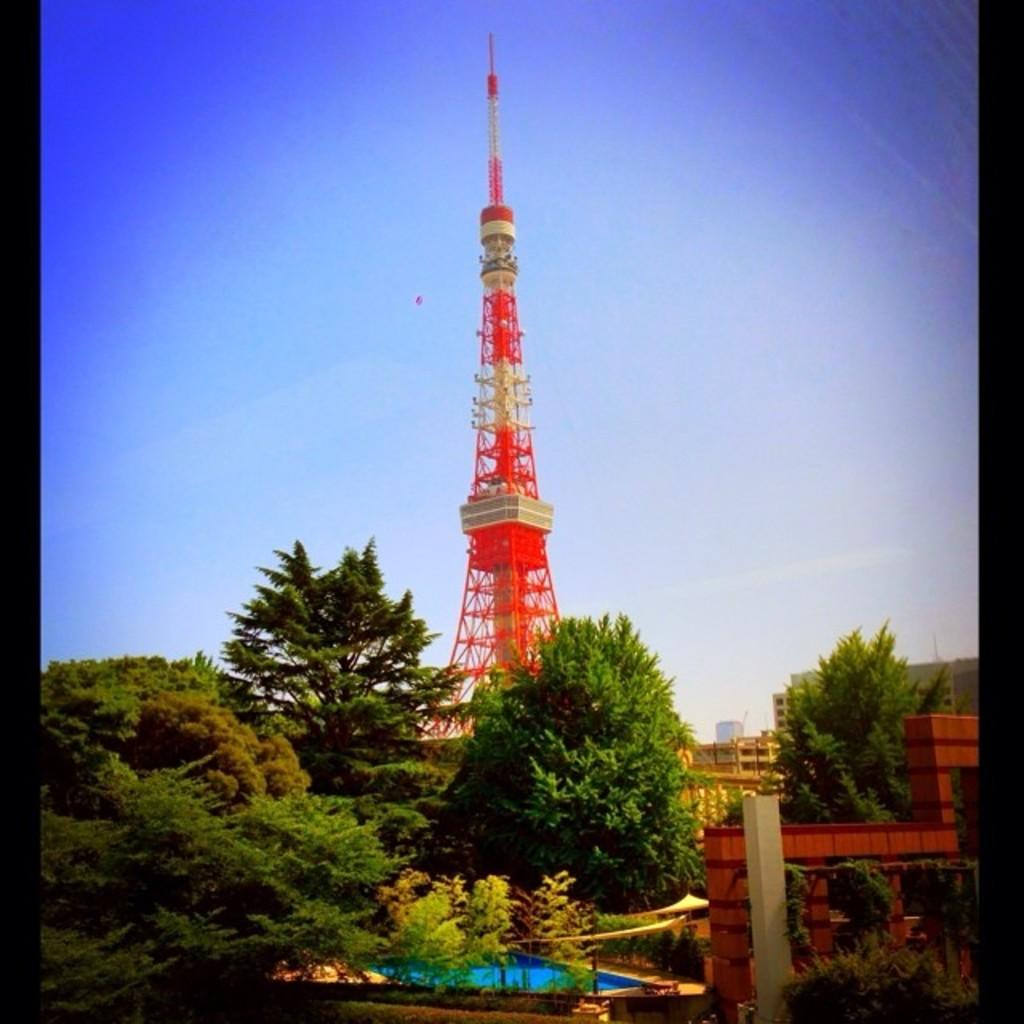What famous landmark is present in the image? There is an Eiffel tower in the image. What type of natural vegetation can be seen in the image? There are trees in the image. What body of water is visible in the image? There is water visible in the image. What part of the natural environment is visible in the image? The sky is visible in the image. What type of brain can be seen floating in the water in the image? There is no brain present in the image; it only features the Eiffel tower, trees, water, and the sky. How many sheep are visible in the image? There are no sheep present in the image. 